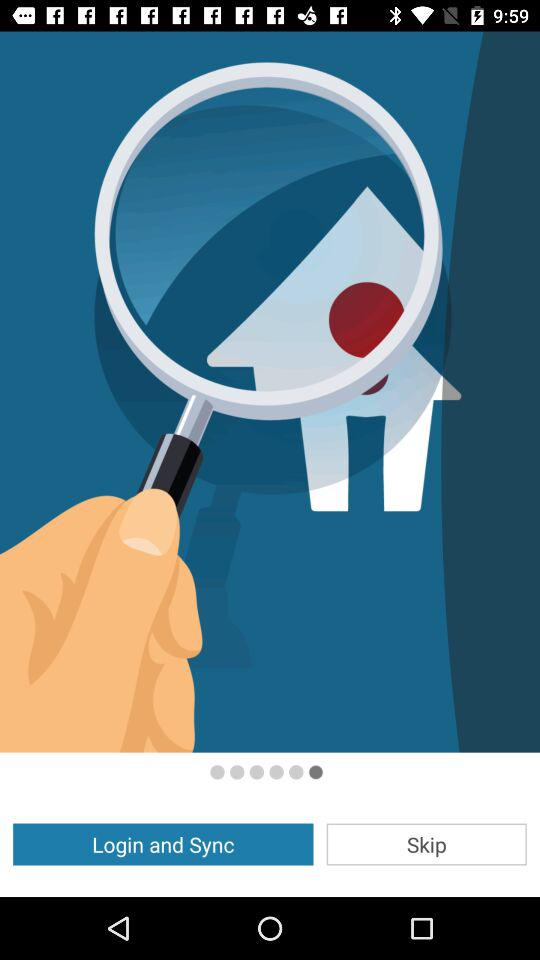What is the selected option? The selected option is "Login and Sync". 